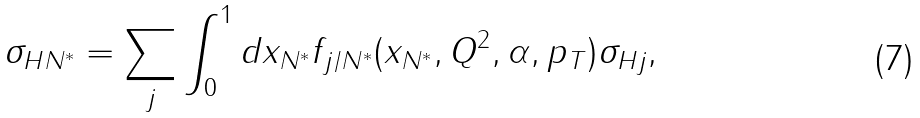Convert formula to latex. <formula><loc_0><loc_0><loc_500><loc_500>\sigma _ { H N ^ { * } } = \sum _ { j } \int _ { 0 } ^ { 1 } d x _ { N ^ { * } } f _ { j / N ^ { * } } ( x _ { N ^ { * } } , Q ^ { 2 } , \alpha , p _ { T } ) \sigma _ { H j } ,</formula> 